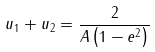Convert formula to latex. <formula><loc_0><loc_0><loc_500><loc_500>u _ { 1 } + u _ { 2 } = { \frac { 2 } { A \left ( 1 - e ^ { 2 } \right ) } }</formula> 